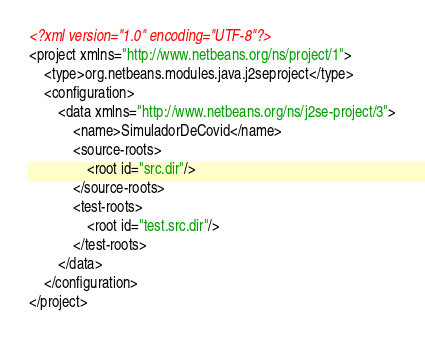<code> <loc_0><loc_0><loc_500><loc_500><_XML_><?xml version="1.0" encoding="UTF-8"?>
<project xmlns="http://www.netbeans.org/ns/project/1">
    <type>org.netbeans.modules.java.j2seproject</type>
    <configuration>
        <data xmlns="http://www.netbeans.org/ns/j2se-project/3">
            <name>SimuladorDeCovid</name>
            <source-roots>
                <root id="src.dir"/>
            </source-roots>
            <test-roots>
                <root id="test.src.dir"/>
            </test-roots>
        </data>
    </configuration>
</project>
</code> 